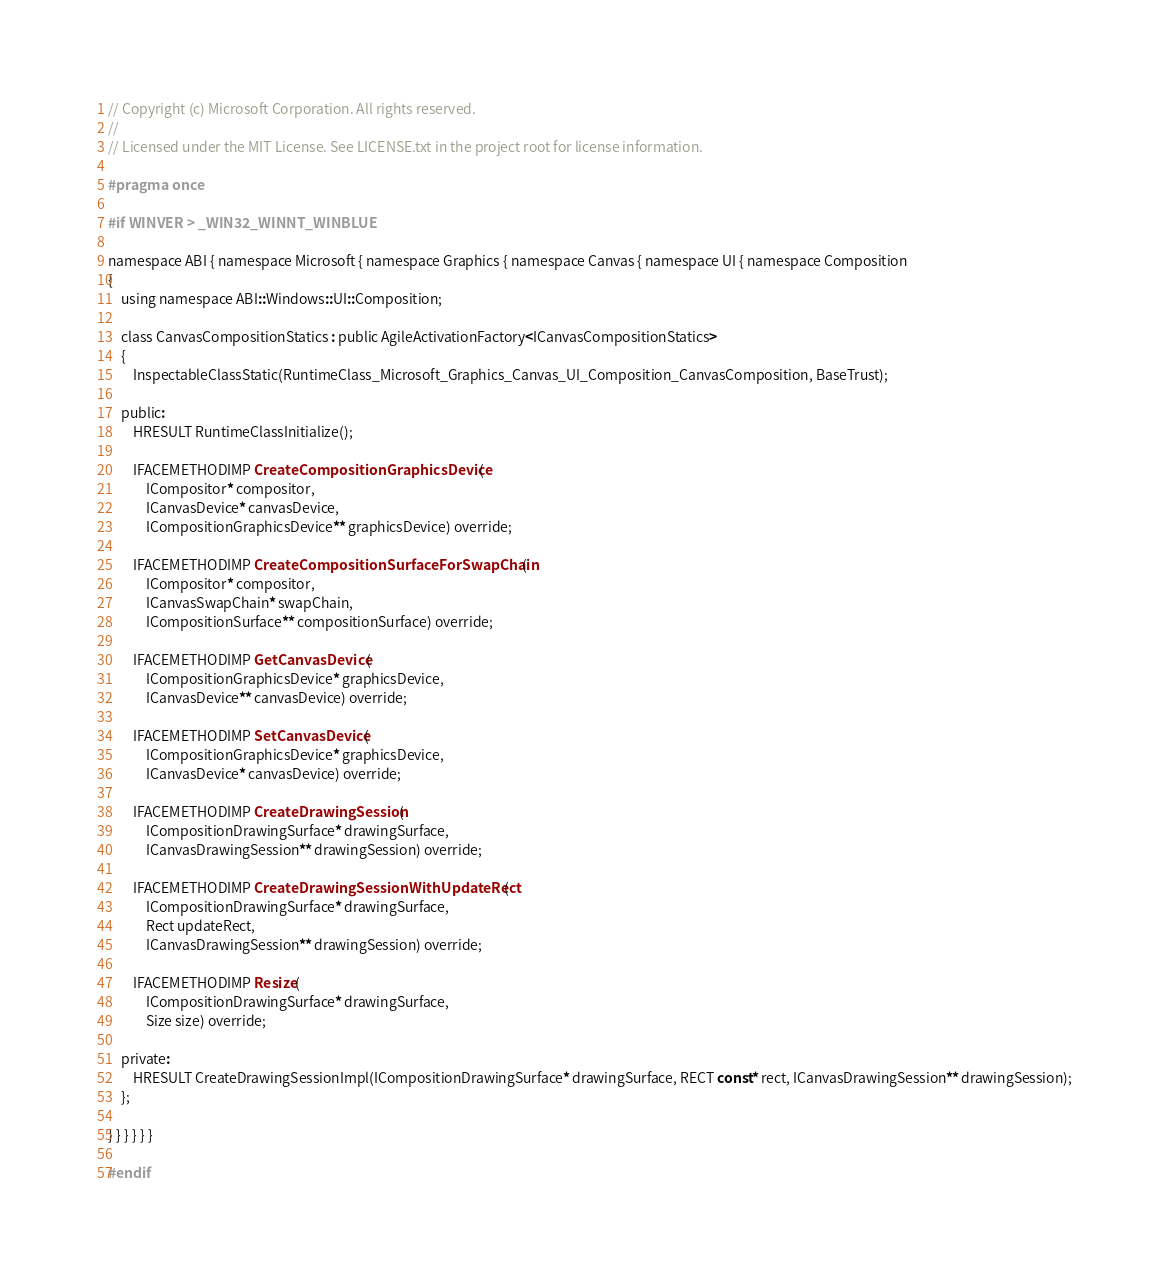<code> <loc_0><loc_0><loc_500><loc_500><_C_>// Copyright (c) Microsoft Corporation. All rights reserved.
//
// Licensed under the MIT License. See LICENSE.txt in the project root for license information.

#pragma once

#if WINVER > _WIN32_WINNT_WINBLUE

namespace ABI { namespace Microsoft { namespace Graphics { namespace Canvas { namespace UI { namespace Composition
{
    using namespace ABI::Windows::UI::Composition;

    class CanvasCompositionStatics : public AgileActivationFactory<ICanvasCompositionStatics>
    {
        InspectableClassStatic(RuntimeClass_Microsoft_Graphics_Canvas_UI_Composition_CanvasComposition, BaseTrust);

    public:
        HRESULT RuntimeClassInitialize();
        
        IFACEMETHODIMP CreateCompositionGraphicsDevice(
            ICompositor* compositor,
            ICanvasDevice* canvasDevice,
            ICompositionGraphicsDevice** graphicsDevice) override;

        IFACEMETHODIMP CreateCompositionSurfaceForSwapChain( 
            ICompositor* compositor,
            ICanvasSwapChain* swapChain,
            ICompositionSurface** compositionSurface) override;
        
        IFACEMETHODIMP GetCanvasDevice( 
            ICompositionGraphicsDevice* graphicsDevice,
            ICanvasDevice** canvasDevice) override;
        
        IFACEMETHODIMP SetCanvasDevice( 
            ICompositionGraphicsDevice* graphicsDevice,
            ICanvasDevice* canvasDevice) override;
        
        IFACEMETHODIMP CreateDrawingSession( 
            ICompositionDrawingSurface* drawingSurface,
            ICanvasDrawingSession** drawingSession) override;

        IFACEMETHODIMP CreateDrawingSessionWithUpdateRect( 
            ICompositionDrawingSurface* drawingSurface,
            Rect updateRect,
            ICanvasDrawingSession** drawingSession) override;

        IFACEMETHODIMP Resize( 
            ICompositionDrawingSurface* drawingSurface,
            Size size) override;

    private:
        HRESULT CreateDrawingSessionImpl(ICompositionDrawingSurface* drawingSurface, RECT const* rect, ICanvasDrawingSession** drawingSession);
    };

} } } } } }

#endif</code> 